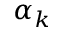Convert formula to latex. <formula><loc_0><loc_0><loc_500><loc_500>\alpha _ { k }</formula> 